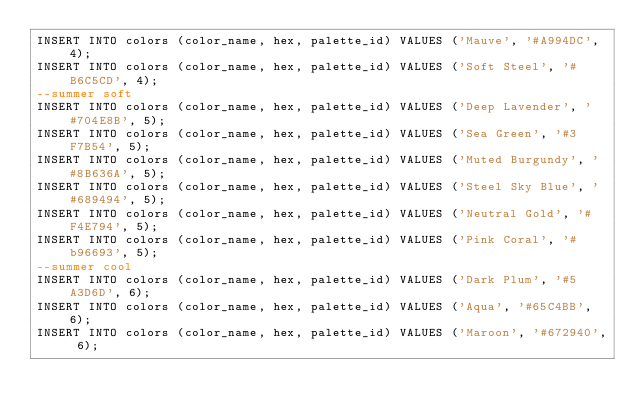<code> <loc_0><loc_0><loc_500><loc_500><_SQL_>INSERT INTO colors (color_name, hex, palette_id) VALUES ('Mauve', '#A994DC', 4);
INSERT INTO colors (color_name, hex, palette_id) VALUES ('Soft Steel', '#B6C5CD', 4);
--summer soft
INSERT INTO colors (color_name, hex, palette_id) VALUES ('Deep Lavender', '#704E8B', 5);
INSERT INTO colors (color_name, hex, palette_id) VALUES ('Sea Green', '#3F7B54', 5);
INSERT INTO colors (color_name, hex, palette_id) VALUES ('Muted Burgundy', '#8B636A', 5);
INSERT INTO colors (color_name, hex, palette_id) VALUES ('Steel Sky Blue', '#689494', 5);
INSERT INTO colors (color_name, hex, palette_id) VALUES ('Neutral Gold', '#F4E794', 5);
INSERT INTO colors (color_name, hex, palette_id) VALUES ('Pink Coral', '#b96693', 5);
--summer cool
INSERT INTO colors (color_name, hex, palette_id) VALUES ('Dark Plum', '#5A3D6D', 6);
INSERT INTO colors (color_name, hex, palette_id) VALUES ('Aqua', '#65C4BB', 6);
INSERT INTO colors (color_name, hex, palette_id) VALUES ('Maroon', '#672940', 6);</code> 